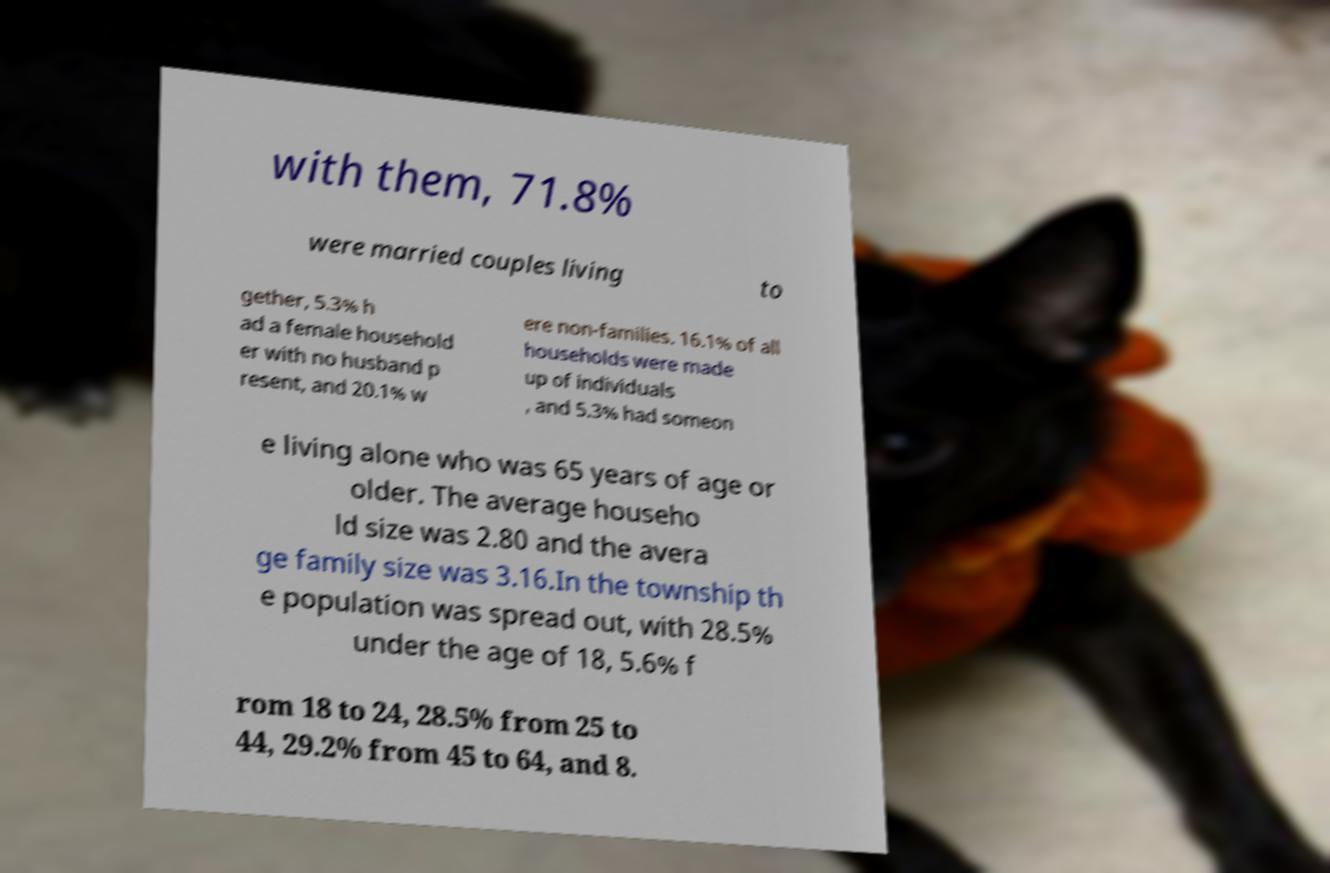Could you extract and type out the text from this image? with them, 71.8% were married couples living to gether, 5.3% h ad a female household er with no husband p resent, and 20.1% w ere non-families. 16.1% of all households were made up of individuals , and 5.3% had someon e living alone who was 65 years of age or older. The average househo ld size was 2.80 and the avera ge family size was 3.16.In the township th e population was spread out, with 28.5% under the age of 18, 5.6% f rom 18 to 24, 28.5% from 25 to 44, 29.2% from 45 to 64, and 8. 